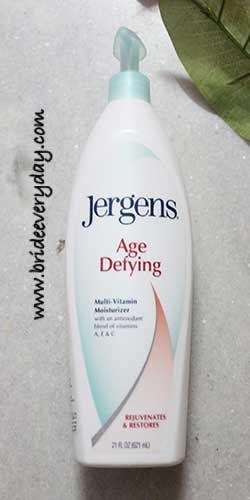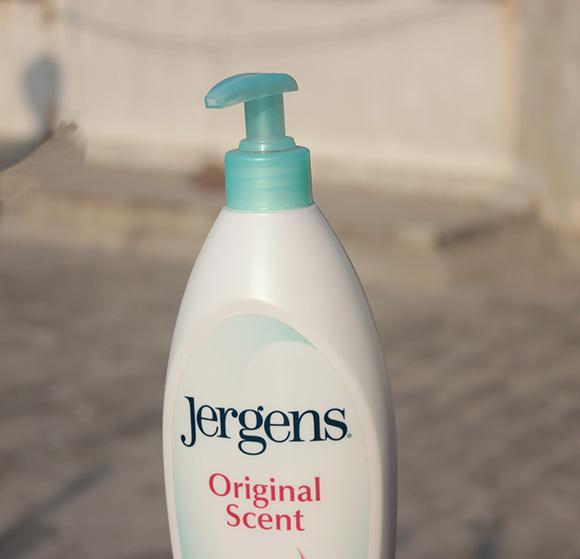The first image is the image on the left, the second image is the image on the right. Considering the images on both sides, is "Left image shows a product with a pump-top dispenser." valid? Answer yes or no. Yes. The first image is the image on the left, the second image is the image on the right. Analyze the images presented: Is the assertion "Only one white bottle is squat and rectangular shaped with rounded edges and a pump top." valid? Answer yes or no. No. 